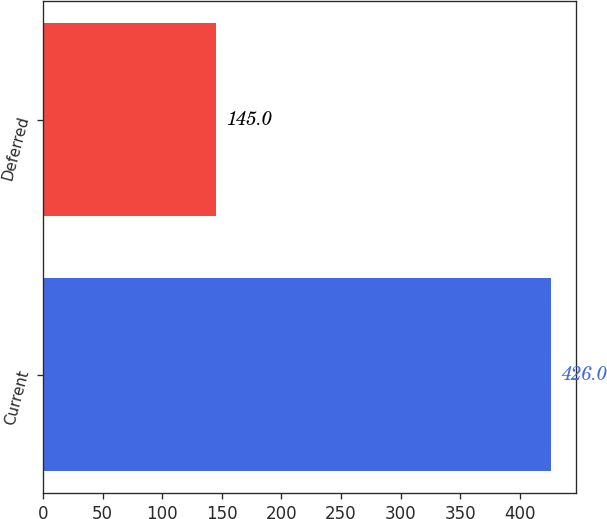Convert chart. <chart><loc_0><loc_0><loc_500><loc_500><bar_chart><fcel>Current<fcel>Deferred<nl><fcel>426<fcel>145<nl></chart> 